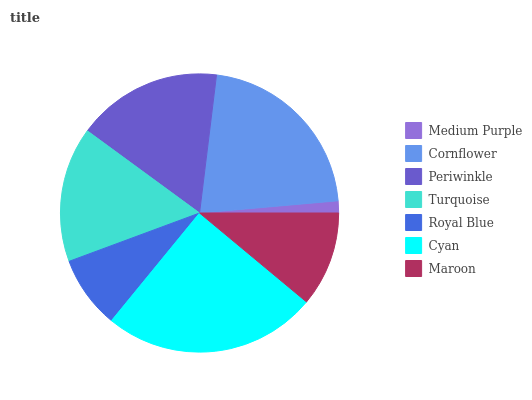Is Medium Purple the minimum?
Answer yes or no. Yes. Is Cyan the maximum?
Answer yes or no. Yes. Is Cornflower the minimum?
Answer yes or no. No. Is Cornflower the maximum?
Answer yes or no. No. Is Cornflower greater than Medium Purple?
Answer yes or no. Yes. Is Medium Purple less than Cornflower?
Answer yes or no. Yes. Is Medium Purple greater than Cornflower?
Answer yes or no. No. Is Cornflower less than Medium Purple?
Answer yes or no. No. Is Turquoise the high median?
Answer yes or no. Yes. Is Turquoise the low median?
Answer yes or no. Yes. Is Cyan the high median?
Answer yes or no. No. Is Maroon the low median?
Answer yes or no. No. 